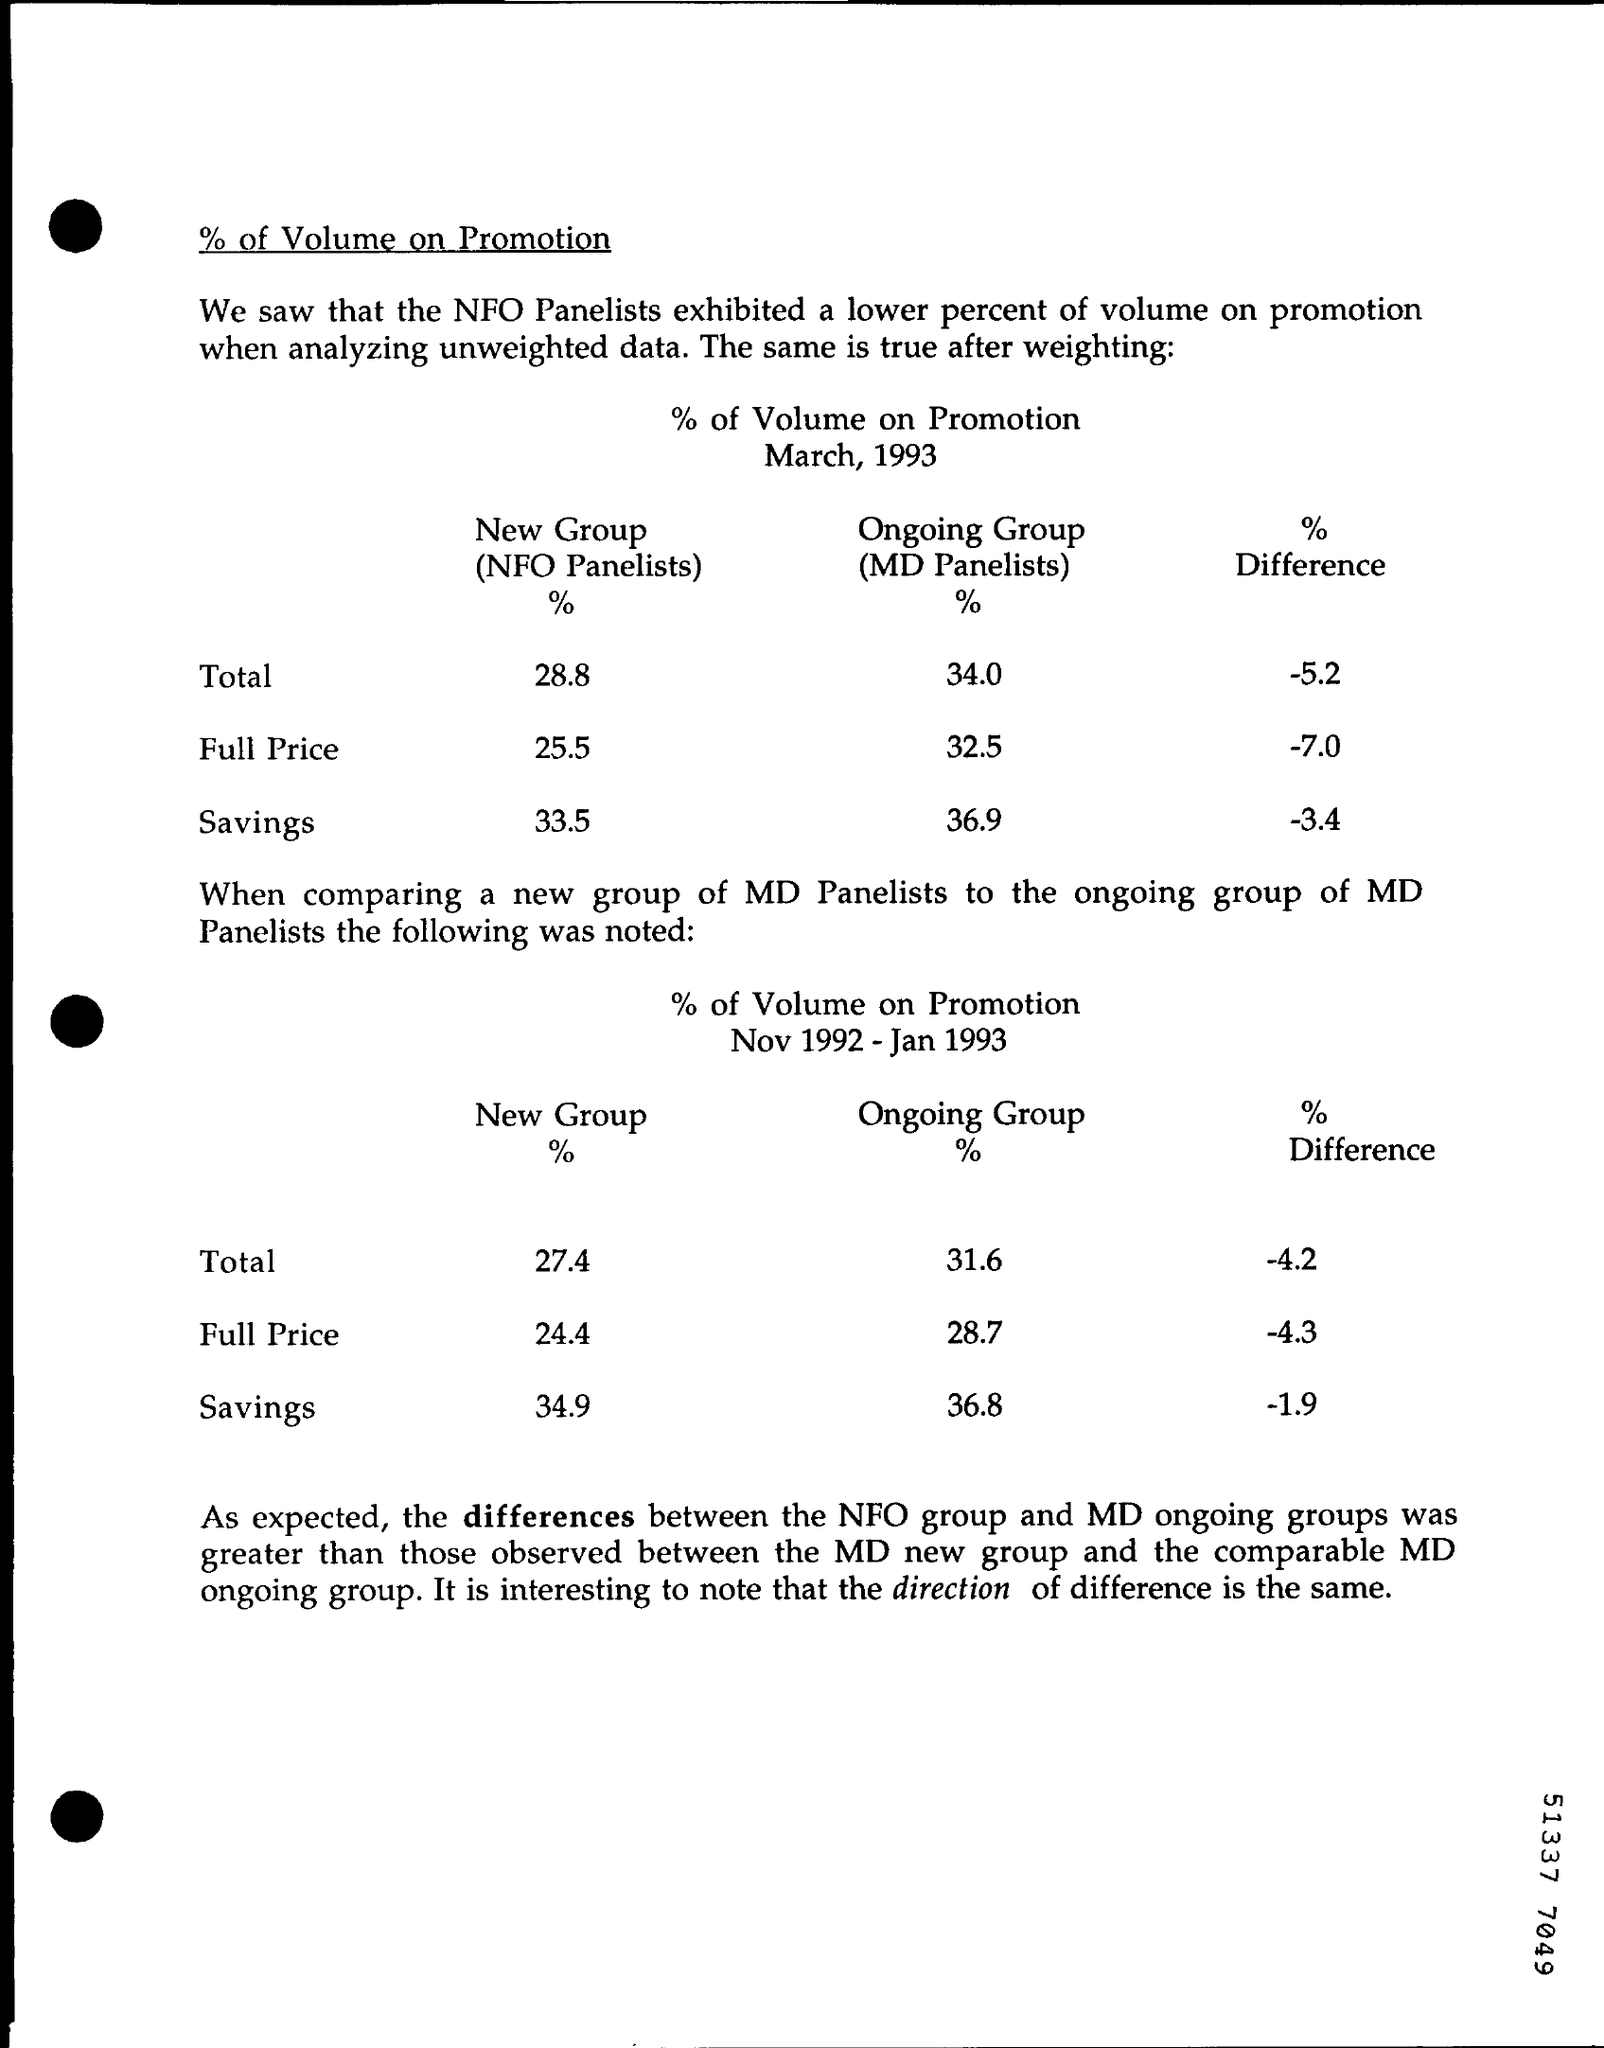Give some essential details in this illustration. The full price new group (NFO panelists) percentage for March, 1993 was 25.5%. In March 1993, the total number of new group panelists was 28.8%. The total ongoing group (MD panelists) percentage for March, 1993 was 34.0%. The savings for the ongoing group (MD panelists) for March, 1993 was 36.9%. I am a language model and I don't have the ability to understand the context of the text you provided. Could you please provide more information about the context and what you are trying to achieve? 